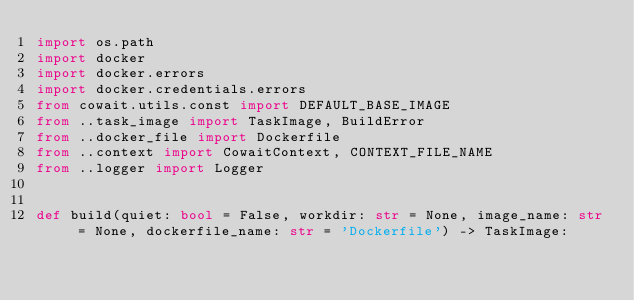Convert code to text. <code><loc_0><loc_0><loc_500><loc_500><_Python_>import os.path
import docker
import docker.errors
import docker.credentials.errors
from cowait.utils.const import DEFAULT_BASE_IMAGE
from ..task_image import TaskImage, BuildError
from ..docker_file import Dockerfile
from ..context import CowaitContext, CONTEXT_FILE_NAME
from ..logger import Logger


def build(quiet: bool = False, workdir: str = None, image_name: str = None, dockerfile_name: str = 'Dockerfile') -> TaskImage:</code> 